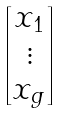<formula> <loc_0><loc_0><loc_500><loc_500>\begin{bmatrix} x _ { 1 } \\ \vdots \\ x _ { g } \end{bmatrix}</formula> 